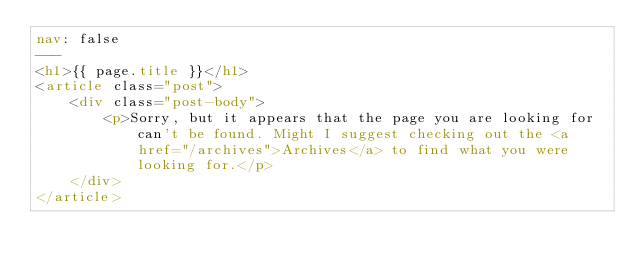Convert code to text. <code><loc_0><loc_0><loc_500><loc_500><_HTML_>nav: false
---
<h1>{{ page.title }}</h1>
<article class="post">
    <div class="post-body">
        <p>Sorry, but it appears that the page you are looking for can't be found. Might I suggest checking out the <a href="/archives">Archives</a> to find what you were looking for.</p>
    </div>
</article></code> 